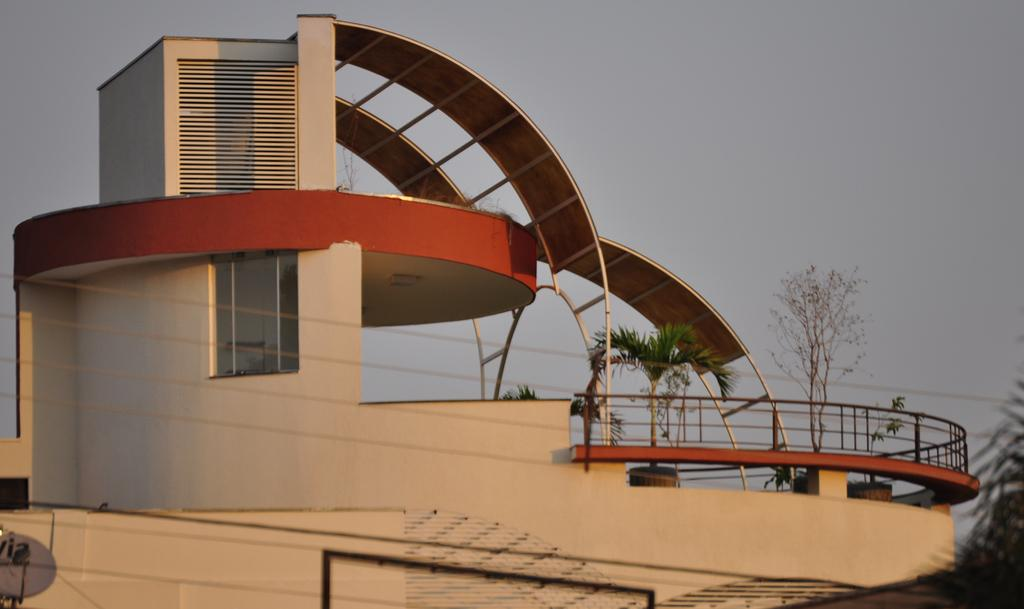What type of structure is visible in the image? There is a building in the image. Can you describe any specific features of the building? There is a window and a railing visible in the image. What else can be seen in the image besides the building? There are plants, wires, and an antenna on the left side at the bottom corner of the image. What is visible in the background of the image? The sky is visible in the image. What type of notebook is being used to record the route in the image? There is no notebook or route present in the image. What attempt is being made by the person in the image? There is no person or attempt visible in the image. 